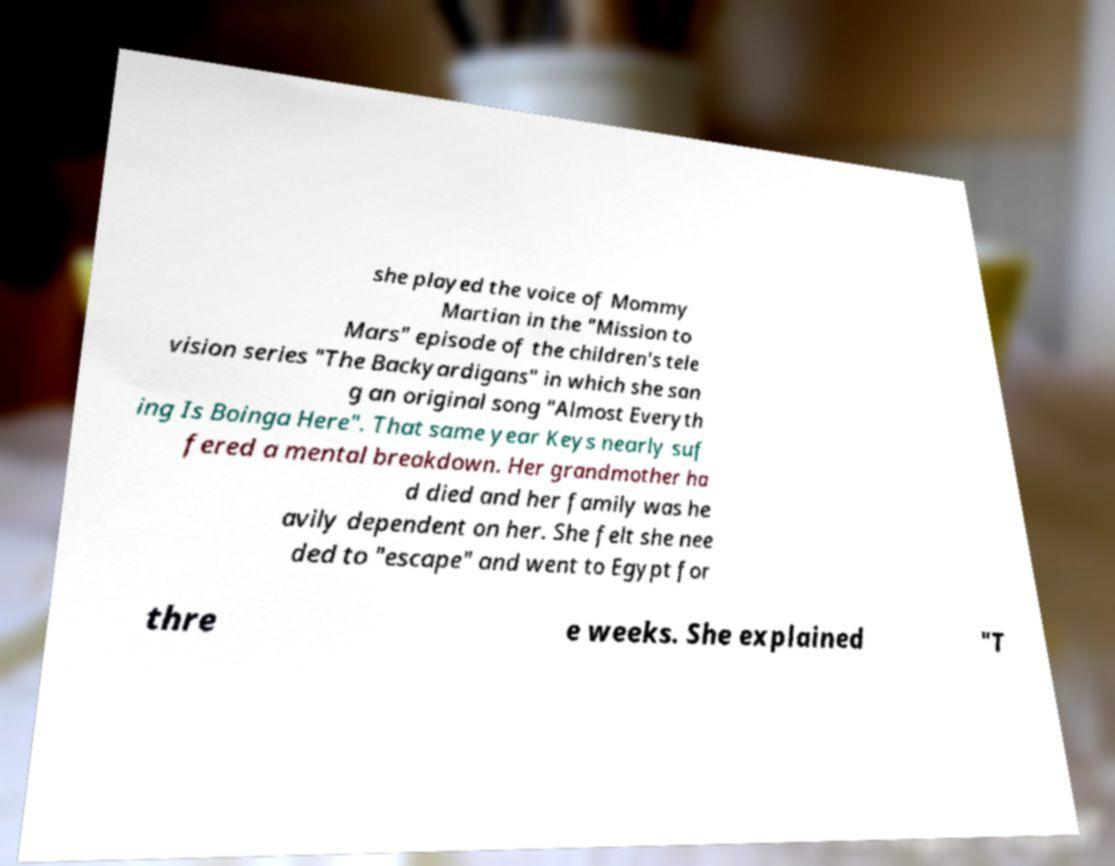Can you accurately transcribe the text from the provided image for me? she played the voice of Mommy Martian in the "Mission to Mars" episode of the children's tele vision series "The Backyardigans" in which she san g an original song "Almost Everyth ing Is Boinga Here". That same year Keys nearly suf fered a mental breakdown. Her grandmother ha d died and her family was he avily dependent on her. She felt she nee ded to "escape" and went to Egypt for thre e weeks. She explained "T 